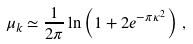<formula> <loc_0><loc_0><loc_500><loc_500>\mu _ { k } \simeq \frac { 1 } { 2 \pi } \ln \left ( 1 + 2 e ^ { - \pi \kappa ^ { 2 } } \right ) \, ,</formula> 